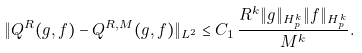Convert formula to latex. <formula><loc_0><loc_0><loc_500><loc_500>\| Q ^ { R } ( g , f ) - Q ^ { R , M } ( g , f ) \| _ { L ^ { 2 } } \leq C _ { 1 } \, \frac { R ^ { k } \| g \| _ { H ^ { k } _ { p } } \| f \| _ { H ^ { k } _ { p } } } { M ^ { k } } .</formula> 